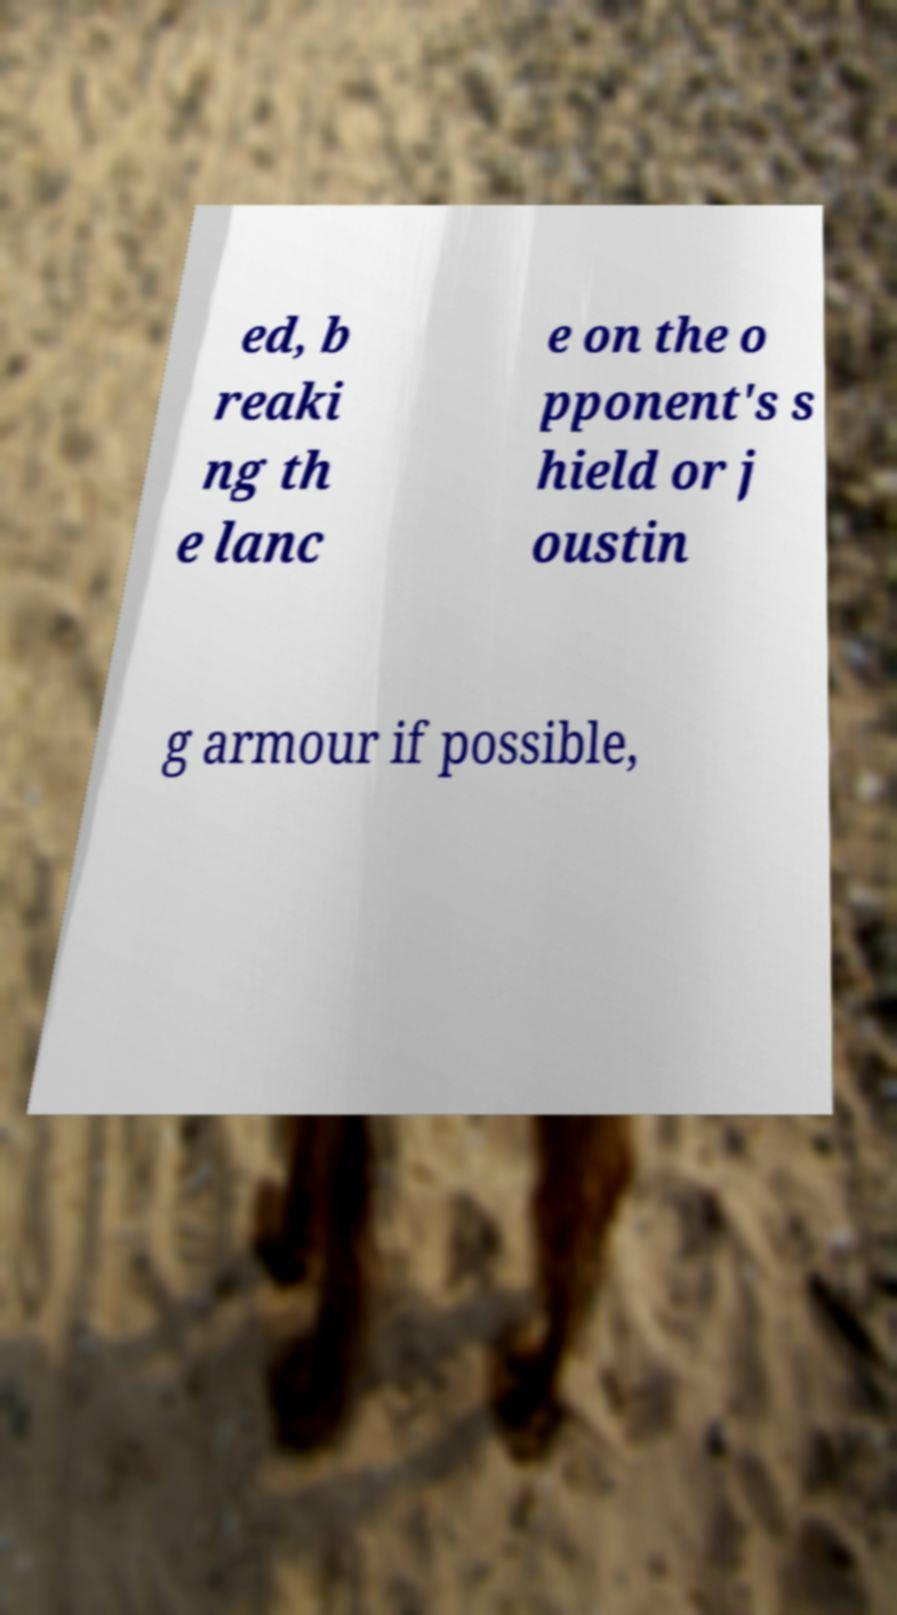Could you assist in decoding the text presented in this image and type it out clearly? ed, b reaki ng th e lanc e on the o pponent's s hield or j oustin g armour if possible, 